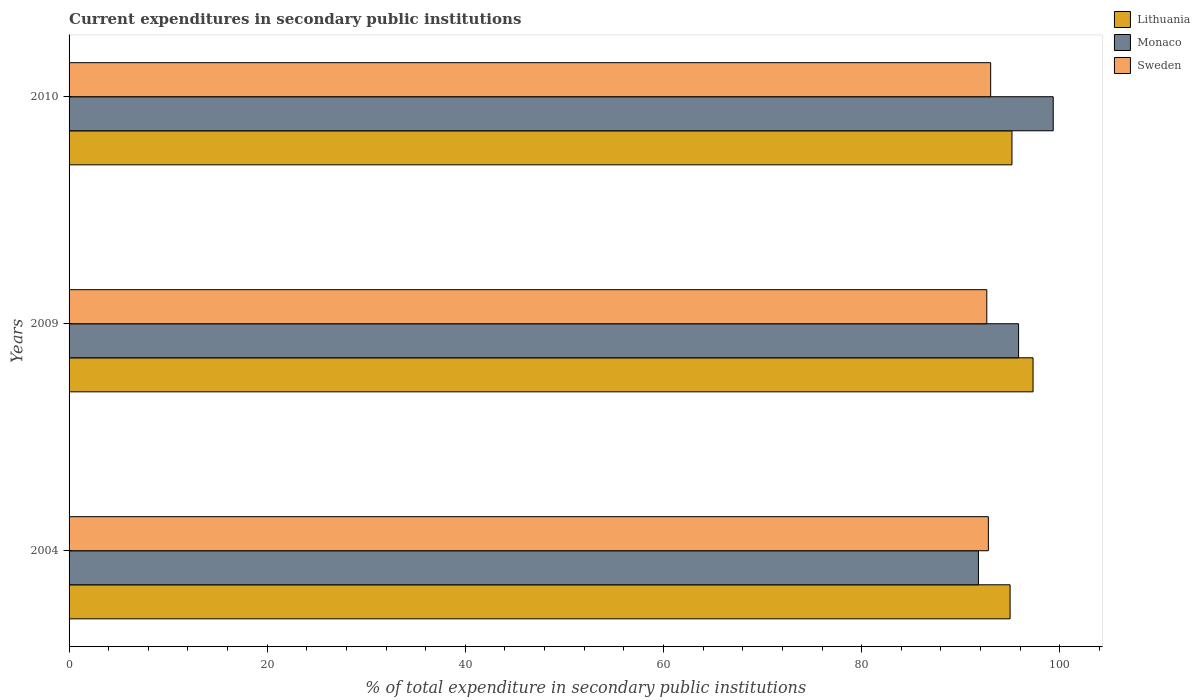How many groups of bars are there?
Keep it short and to the point. 3. Are the number of bars on each tick of the Y-axis equal?
Offer a very short reply. Yes. How many bars are there on the 2nd tick from the bottom?
Your answer should be very brief. 3. What is the label of the 3rd group of bars from the top?
Offer a terse response. 2004. What is the current expenditures in secondary public institutions in Monaco in 2010?
Offer a very short reply. 99.34. Across all years, what is the maximum current expenditures in secondary public institutions in Lithuania?
Your answer should be compact. 97.3. Across all years, what is the minimum current expenditures in secondary public institutions in Lithuania?
Ensure brevity in your answer.  94.99. What is the total current expenditures in secondary public institutions in Monaco in the graph?
Provide a short and direct response. 286.97. What is the difference between the current expenditures in secondary public institutions in Monaco in 2004 and that in 2010?
Provide a short and direct response. -7.55. What is the difference between the current expenditures in secondary public institutions in Sweden in 2004 and the current expenditures in secondary public institutions in Lithuania in 2010?
Your answer should be compact. -2.38. What is the average current expenditures in secondary public institutions in Lithuania per year?
Your response must be concise. 95.82. In the year 2009, what is the difference between the current expenditures in secondary public institutions in Sweden and current expenditures in secondary public institutions in Monaco?
Give a very brief answer. -3.21. What is the ratio of the current expenditures in secondary public institutions in Lithuania in 2004 to that in 2010?
Offer a terse response. 1. Is the current expenditures in secondary public institutions in Monaco in 2004 less than that in 2010?
Your answer should be very brief. Yes. What is the difference between the highest and the second highest current expenditures in secondary public institutions in Lithuania?
Offer a very short reply. 2.13. What is the difference between the highest and the lowest current expenditures in secondary public institutions in Lithuania?
Make the answer very short. 2.32. Is the sum of the current expenditures in secondary public institutions in Sweden in 2009 and 2010 greater than the maximum current expenditures in secondary public institutions in Monaco across all years?
Give a very brief answer. Yes. What does the 3rd bar from the bottom in 2004 represents?
Your response must be concise. Sweden. How many bars are there?
Offer a very short reply. 9. What is the difference between two consecutive major ticks on the X-axis?
Provide a short and direct response. 20. Does the graph contain any zero values?
Your response must be concise. No. How are the legend labels stacked?
Provide a short and direct response. Vertical. What is the title of the graph?
Offer a terse response. Current expenditures in secondary public institutions. What is the label or title of the X-axis?
Your answer should be compact. % of total expenditure in secondary public institutions. What is the label or title of the Y-axis?
Your response must be concise. Years. What is the % of total expenditure in secondary public institutions in Lithuania in 2004?
Keep it short and to the point. 94.99. What is the % of total expenditure in secondary public institutions in Monaco in 2004?
Your response must be concise. 91.79. What is the % of total expenditure in secondary public institutions of Sweden in 2004?
Your answer should be very brief. 92.79. What is the % of total expenditure in secondary public institutions in Lithuania in 2009?
Provide a short and direct response. 97.3. What is the % of total expenditure in secondary public institutions of Monaco in 2009?
Your answer should be very brief. 95.84. What is the % of total expenditure in secondary public institutions of Sweden in 2009?
Make the answer very short. 92.63. What is the % of total expenditure in secondary public institutions in Lithuania in 2010?
Provide a succinct answer. 95.18. What is the % of total expenditure in secondary public institutions in Monaco in 2010?
Your answer should be compact. 99.34. What is the % of total expenditure in secondary public institutions of Sweden in 2010?
Provide a short and direct response. 93.02. Across all years, what is the maximum % of total expenditure in secondary public institutions of Lithuania?
Your answer should be very brief. 97.3. Across all years, what is the maximum % of total expenditure in secondary public institutions in Monaco?
Make the answer very short. 99.34. Across all years, what is the maximum % of total expenditure in secondary public institutions of Sweden?
Ensure brevity in your answer.  93.02. Across all years, what is the minimum % of total expenditure in secondary public institutions of Lithuania?
Keep it short and to the point. 94.99. Across all years, what is the minimum % of total expenditure in secondary public institutions of Monaco?
Your response must be concise. 91.79. Across all years, what is the minimum % of total expenditure in secondary public institutions of Sweden?
Offer a terse response. 92.63. What is the total % of total expenditure in secondary public institutions in Lithuania in the graph?
Your response must be concise. 287.47. What is the total % of total expenditure in secondary public institutions of Monaco in the graph?
Keep it short and to the point. 286.97. What is the total % of total expenditure in secondary public institutions in Sweden in the graph?
Provide a succinct answer. 278.45. What is the difference between the % of total expenditure in secondary public institutions of Lithuania in 2004 and that in 2009?
Ensure brevity in your answer.  -2.32. What is the difference between the % of total expenditure in secondary public institutions in Monaco in 2004 and that in 2009?
Your response must be concise. -4.05. What is the difference between the % of total expenditure in secondary public institutions in Sweden in 2004 and that in 2009?
Offer a very short reply. 0.16. What is the difference between the % of total expenditure in secondary public institutions of Lithuania in 2004 and that in 2010?
Offer a terse response. -0.19. What is the difference between the % of total expenditure in secondary public institutions in Monaco in 2004 and that in 2010?
Offer a terse response. -7.55. What is the difference between the % of total expenditure in secondary public institutions of Sweden in 2004 and that in 2010?
Offer a very short reply. -0.23. What is the difference between the % of total expenditure in secondary public institutions of Lithuania in 2009 and that in 2010?
Provide a succinct answer. 2.13. What is the difference between the % of total expenditure in secondary public institutions in Monaco in 2009 and that in 2010?
Keep it short and to the point. -3.5. What is the difference between the % of total expenditure in secondary public institutions in Sweden in 2009 and that in 2010?
Keep it short and to the point. -0.39. What is the difference between the % of total expenditure in secondary public institutions of Lithuania in 2004 and the % of total expenditure in secondary public institutions of Monaco in 2009?
Your response must be concise. -0.86. What is the difference between the % of total expenditure in secondary public institutions in Lithuania in 2004 and the % of total expenditure in secondary public institutions in Sweden in 2009?
Keep it short and to the point. 2.35. What is the difference between the % of total expenditure in secondary public institutions in Monaco in 2004 and the % of total expenditure in secondary public institutions in Sweden in 2009?
Make the answer very short. -0.85. What is the difference between the % of total expenditure in secondary public institutions in Lithuania in 2004 and the % of total expenditure in secondary public institutions in Monaco in 2010?
Your answer should be very brief. -4.35. What is the difference between the % of total expenditure in secondary public institutions in Lithuania in 2004 and the % of total expenditure in secondary public institutions in Sweden in 2010?
Your answer should be compact. 1.96. What is the difference between the % of total expenditure in secondary public institutions of Monaco in 2004 and the % of total expenditure in secondary public institutions of Sweden in 2010?
Offer a terse response. -1.24. What is the difference between the % of total expenditure in secondary public institutions in Lithuania in 2009 and the % of total expenditure in secondary public institutions in Monaco in 2010?
Your answer should be very brief. -2.03. What is the difference between the % of total expenditure in secondary public institutions of Lithuania in 2009 and the % of total expenditure in secondary public institutions of Sweden in 2010?
Offer a very short reply. 4.28. What is the difference between the % of total expenditure in secondary public institutions of Monaco in 2009 and the % of total expenditure in secondary public institutions of Sweden in 2010?
Provide a succinct answer. 2.82. What is the average % of total expenditure in secondary public institutions in Lithuania per year?
Offer a very short reply. 95.82. What is the average % of total expenditure in secondary public institutions in Monaco per year?
Your answer should be very brief. 95.66. What is the average % of total expenditure in secondary public institutions in Sweden per year?
Provide a succinct answer. 92.82. In the year 2004, what is the difference between the % of total expenditure in secondary public institutions of Lithuania and % of total expenditure in secondary public institutions of Monaco?
Offer a very short reply. 3.2. In the year 2004, what is the difference between the % of total expenditure in secondary public institutions in Lithuania and % of total expenditure in secondary public institutions in Sweden?
Provide a succinct answer. 2.19. In the year 2004, what is the difference between the % of total expenditure in secondary public institutions of Monaco and % of total expenditure in secondary public institutions of Sweden?
Your answer should be compact. -1. In the year 2009, what is the difference between the % of total expenditure in secondary public institutions in Lithuania and % of total expenditure in secondary public institutions in Monaco?
Provide a short and direct response. 1.46. In the year 2009, what is the difference between the % of total expenditure in secondary public institutions of Lithuania and % of total expenditure in secondary public institutions of Sweden?
Give a very brief answer. 4.67. In the year 2009, what is the difference between the % of total expenditure in secondary public institutions of Monaco and % of total expenditure in secondary public institutions of Sweden?
Keep it short and to the point. 3.21. In the year 2010, what is the difference between the % of total expenditure in secondary public institutions in Lithuania and % of total expenditure in secondary public institutions in Monaco?
Your response must be concise. -4.16. In the year 2010, what is the difference between the % of total expenditure in secondary public institutions of Lithuania and % of total expenditure in secondary public institutions of Sweden?
Your response must be concise. 2.15. In the year 2010, what is the difference between the % of total expenditure in secondary public institutions in Monaco and % of total expenditure in secondary public institutions in Sweden?
Your response must be concise. 6.31. What is the ratio of the % of total expenditure in secondary public institutions of Lithuania in 2004 to that in 2009?
Your answer should be very brief. 0.98. What is the ratio of the % of total expenditure in secondary public institutions in Monaco in 2004 to that in 2009?
Provide a succinct answer. 0.96. What is the ratio of the % of total expenditure in secondary public institutions of Lithuania in 2004 to that in 2010?
Make the answer very short. 1. What is the ratio of the % of total expenditure in secondary public institutions of Monaco in 2004 to that in 2010?
Your response must be concise. 0.92. What is the ratio of the % of total expenditure in secondary public institutions in Lithuania in 2009 to that in 2010?
Make the answer very short. 1.02. What is the ratio of the % of total expenditure in secondary public institutions of Monaco in 2009 to that in 2010?
Offer a terse response. 0.96. What is the ratio of the % of total expenditure in secondary public institutions in Sweden in 2009 to that in 2010?
Your answer should be very brief. 1. What is the difference between the highest and the second highest % of total expenditure in secondary public institutions in Lithuania?
Your answer should be very brief. 2.13. What is the difference between the highest and the second highest % of total expenditure in secondary public institutions in Monaco?
Offer a terse response. 3.5. What is the difference between the highest and the second highest % of total expenditure in secondary public institutions of Sweden?
Make the answer very short. 0.23. What is the difference between the highest and the lowest % of total expenditure in secondary public institutions in Lithuania?
Offer a terse response. 2.32. What is the difference between the highest and the lowest % of total expenditure in secondary public institutions of Monaco?
Give a very brief answer. 7.55. What is the difference between the highest and the lowest % of total expenditure in secondary public institutions in Sweden?
Provide a short and direct response. 0.39. 